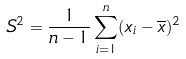Convert formula to latex. <formula><loc_0><loc_0><loc_500><loc_500>S ^ { 2 } = \frac { 1 } { n - 1 } \sum _ { i = 1 } ^ { n } ( x _ { i } - \overline { x } ) ^ { 2 }</formula> 